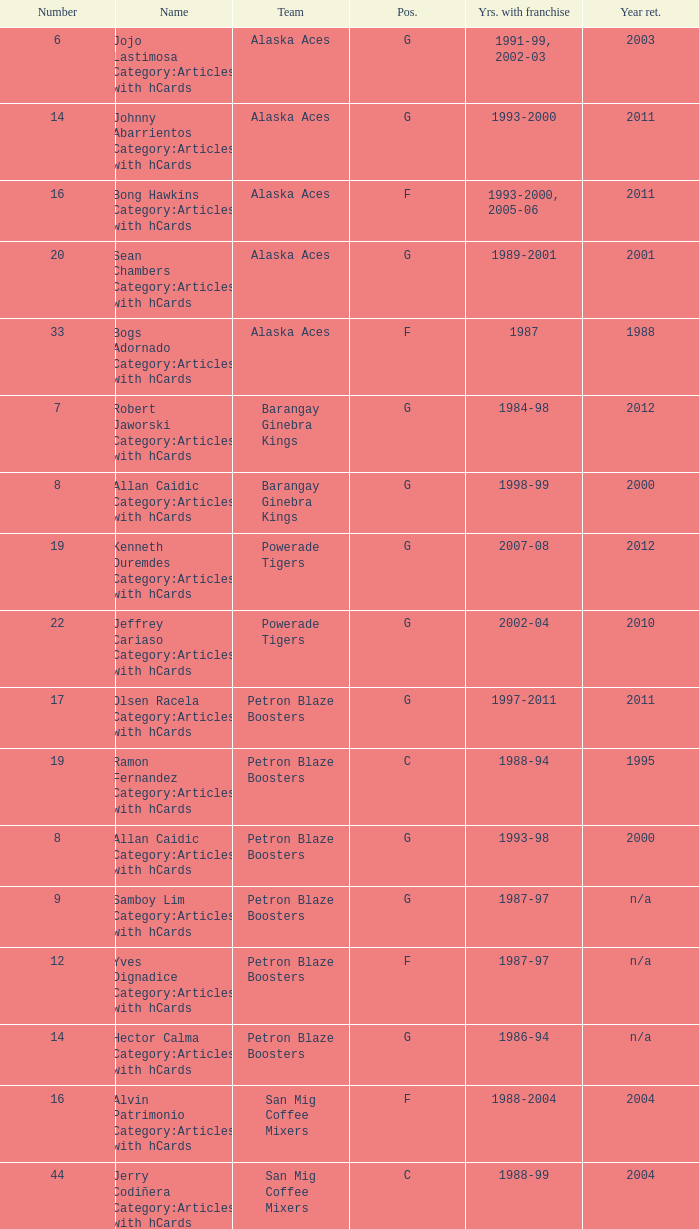Which team is number 14 and had a franchise in 1993-2000? Alaska Aces. 